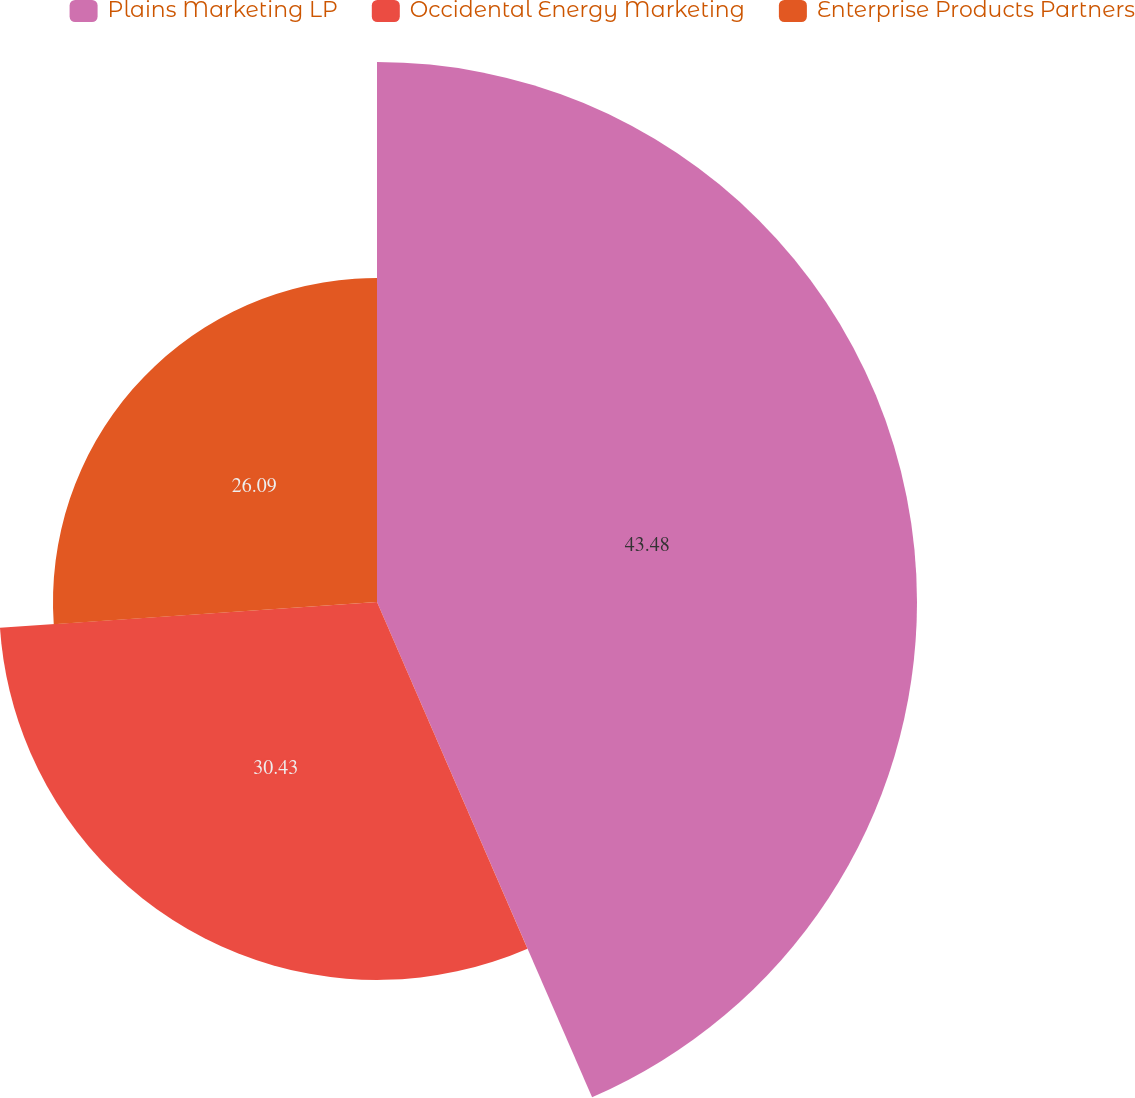Convert chart to OTSL. <chart><loc_0><loc_0><loc_500><loc_500><pie_chart><fcel>Plains Marketing LP<fcel>Occidental Energy Marketing<fcel>Enterprise Products Partners<nl><fcel>43.48%<fcel>30.43%<fcel>26.09%<nl></chart> 